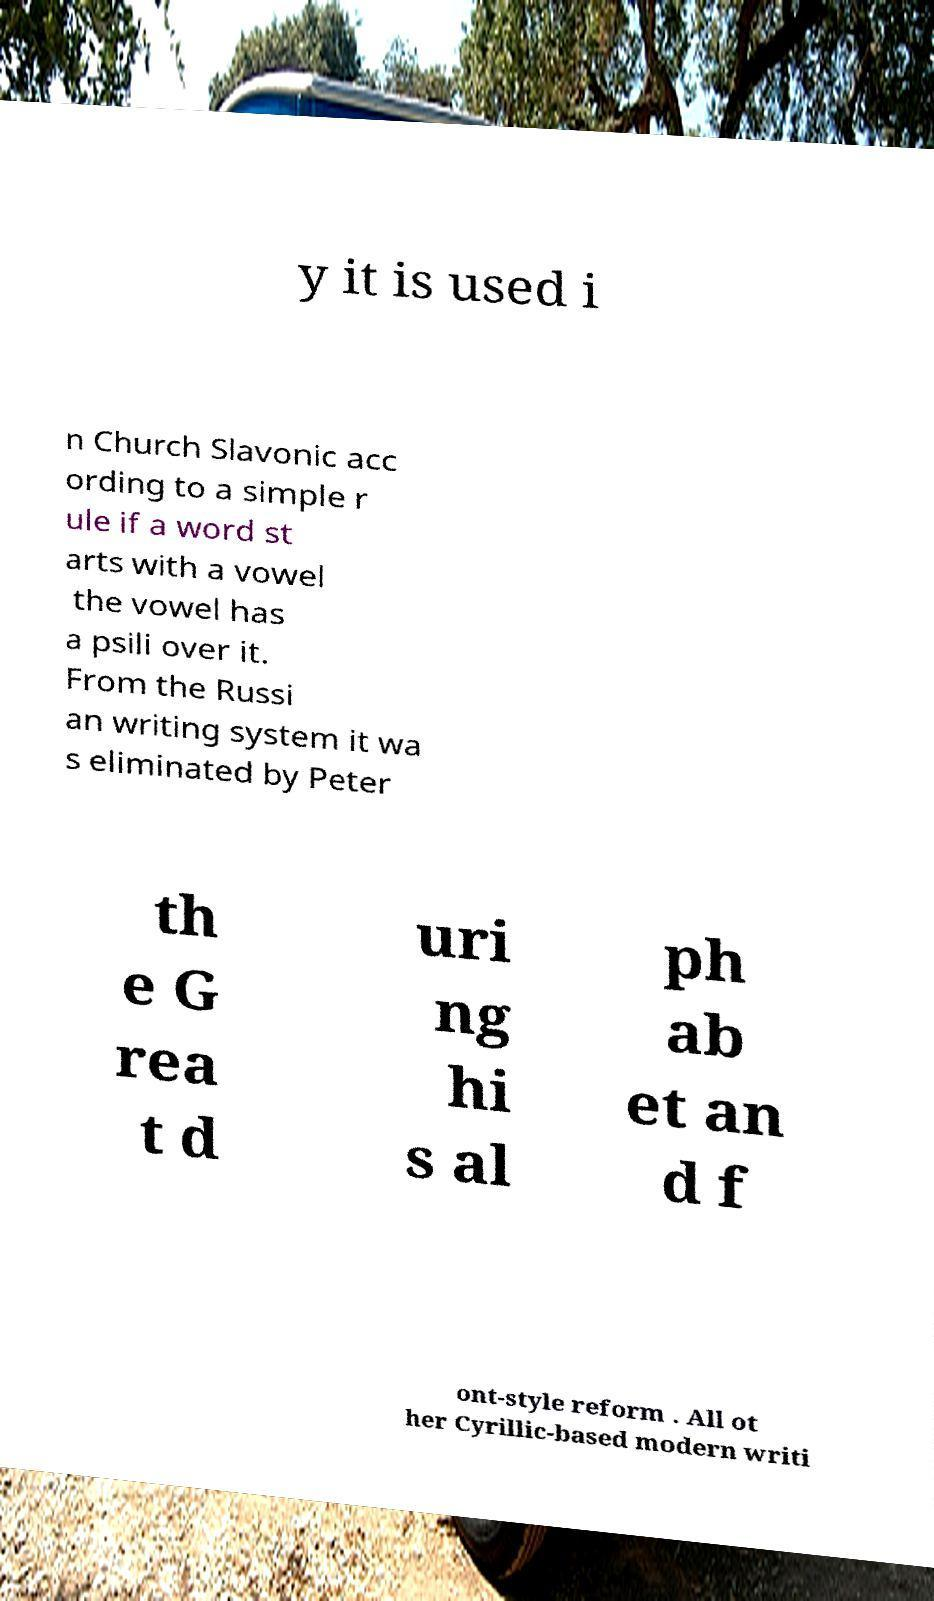Could you extract and type out the text from this image? y it is used i n Church Slavonic acc ording to a simple r ule if a word st arts with a vowel the vowel has a psili over it. From the Russi an writing system it wa s eliminated by Peter th e G rea t d uri ng hi s al ph ab et an d f ont-style reform . All ot her Cyrillic-based modern writi 